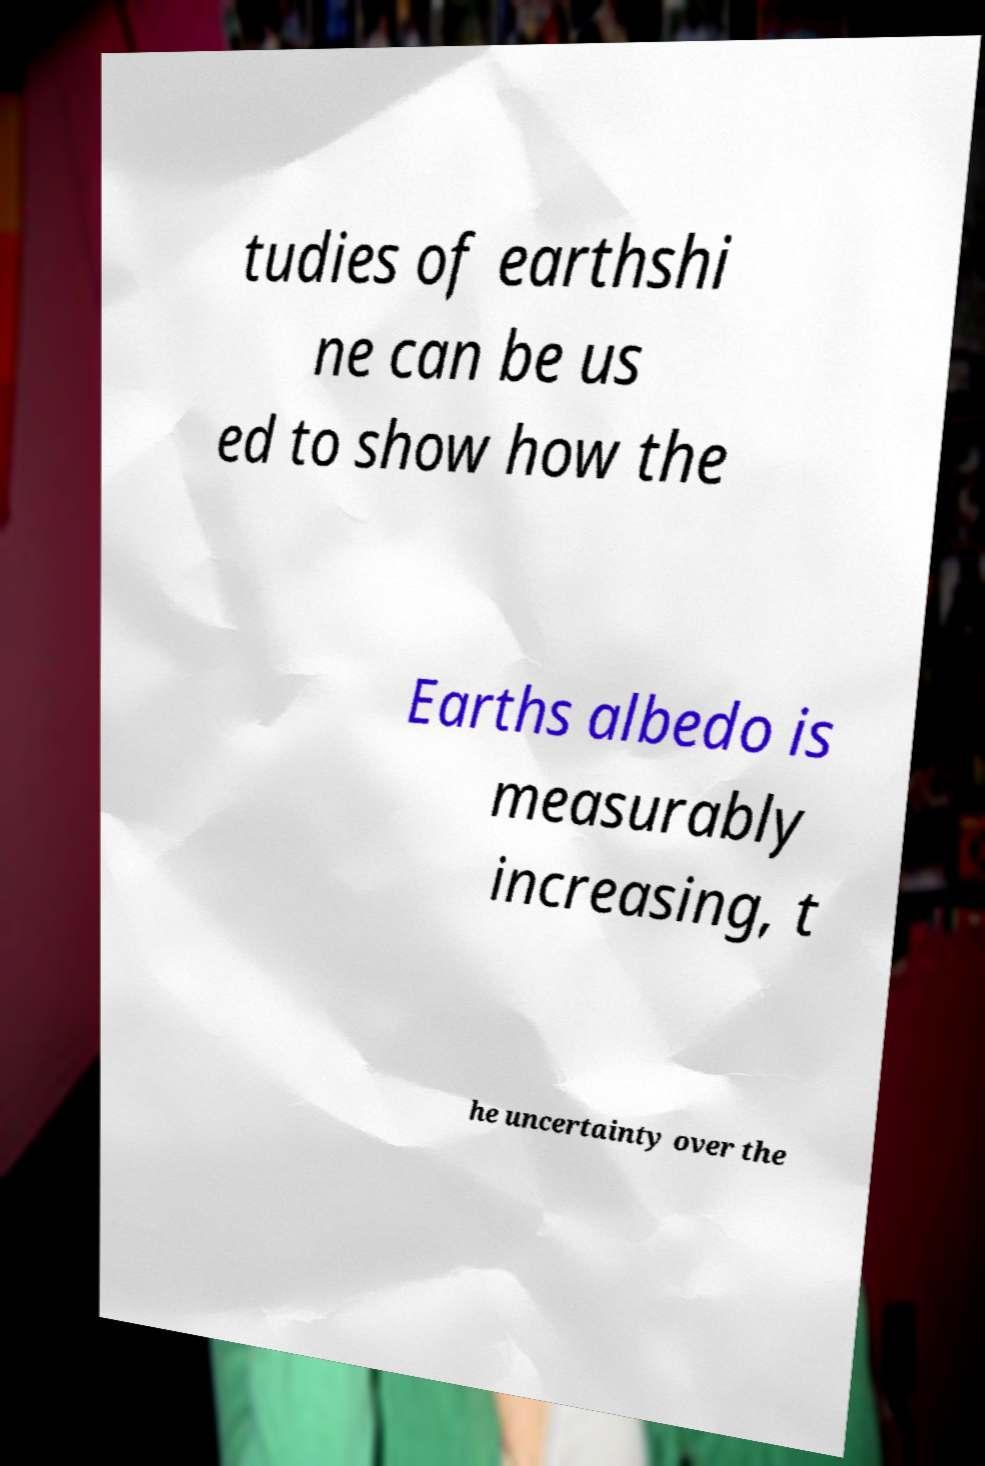I need the written content from this picture converted into text. Can you do that? tudies of earthshi ne can be us ed to show how the Earths albedo is measurably increasing, t he uncertainty over the 